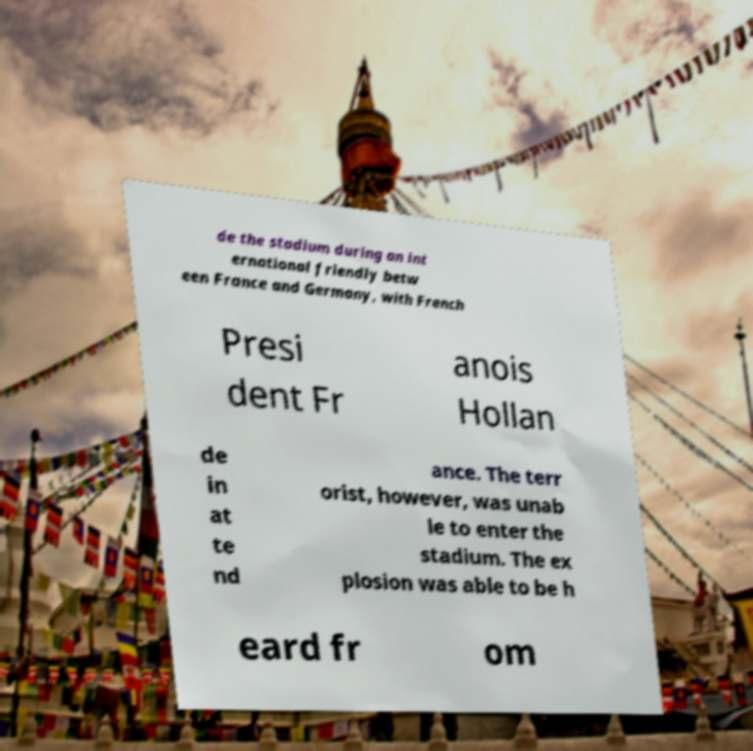Please read and relay the text visible in this image. What does it say? de the stadium during an int ernational friendly betw een France and Germany, with French Presi dent Fr anois Hollan de in at te nd ance. The terr orist, however, was unab le to enter the stadium. The ex plosion was able to be h eard fr om 